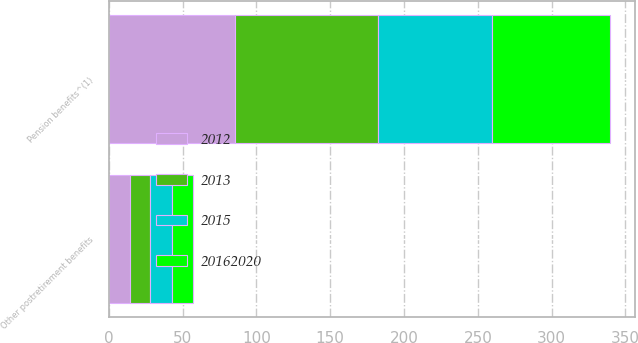<chart> <loc_0><loc_0><loc_500><loc_500><stacked_bar_chart><ecel><fcel>Pension benefits^(1)<fcel>Other postretirement benefits<nl><fcel>2015<fcel>77.4<fcel>15.1<nl><fcel>2012<fcel>85.2<fcel>14.4<nl><fcel>2.0162e+07<fcel>79.7<fcel>14<nl><fcel>2013<fcel>97.2<fcel>13.5<nl></chart> 